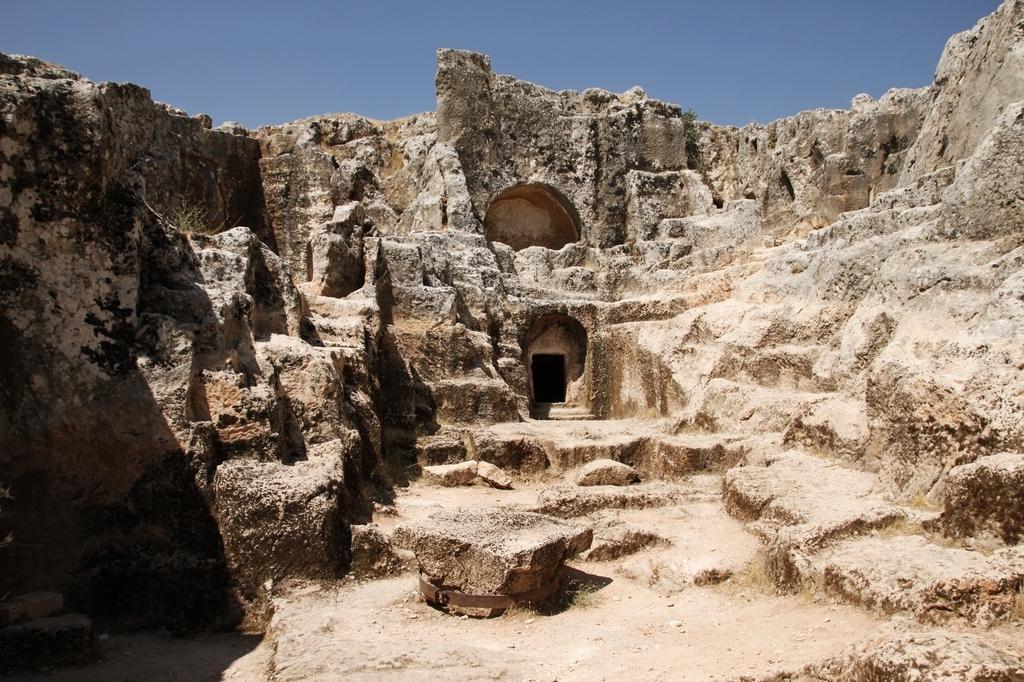What is the main feature of the image? There is a huge rock mountain in the image. What is depicted on the rock? Something is carved on the rock. What can be seen in the background of the image? The sky is visible in the background of the image. How many insects can be seen crawling on the rock in the image? There are no insects visible in the image; it features a huge rock mountain with a carving on it. What type of death is depicted on the rock in the image? There is no depiction of death on the rock in the image; it only shows a carving. 